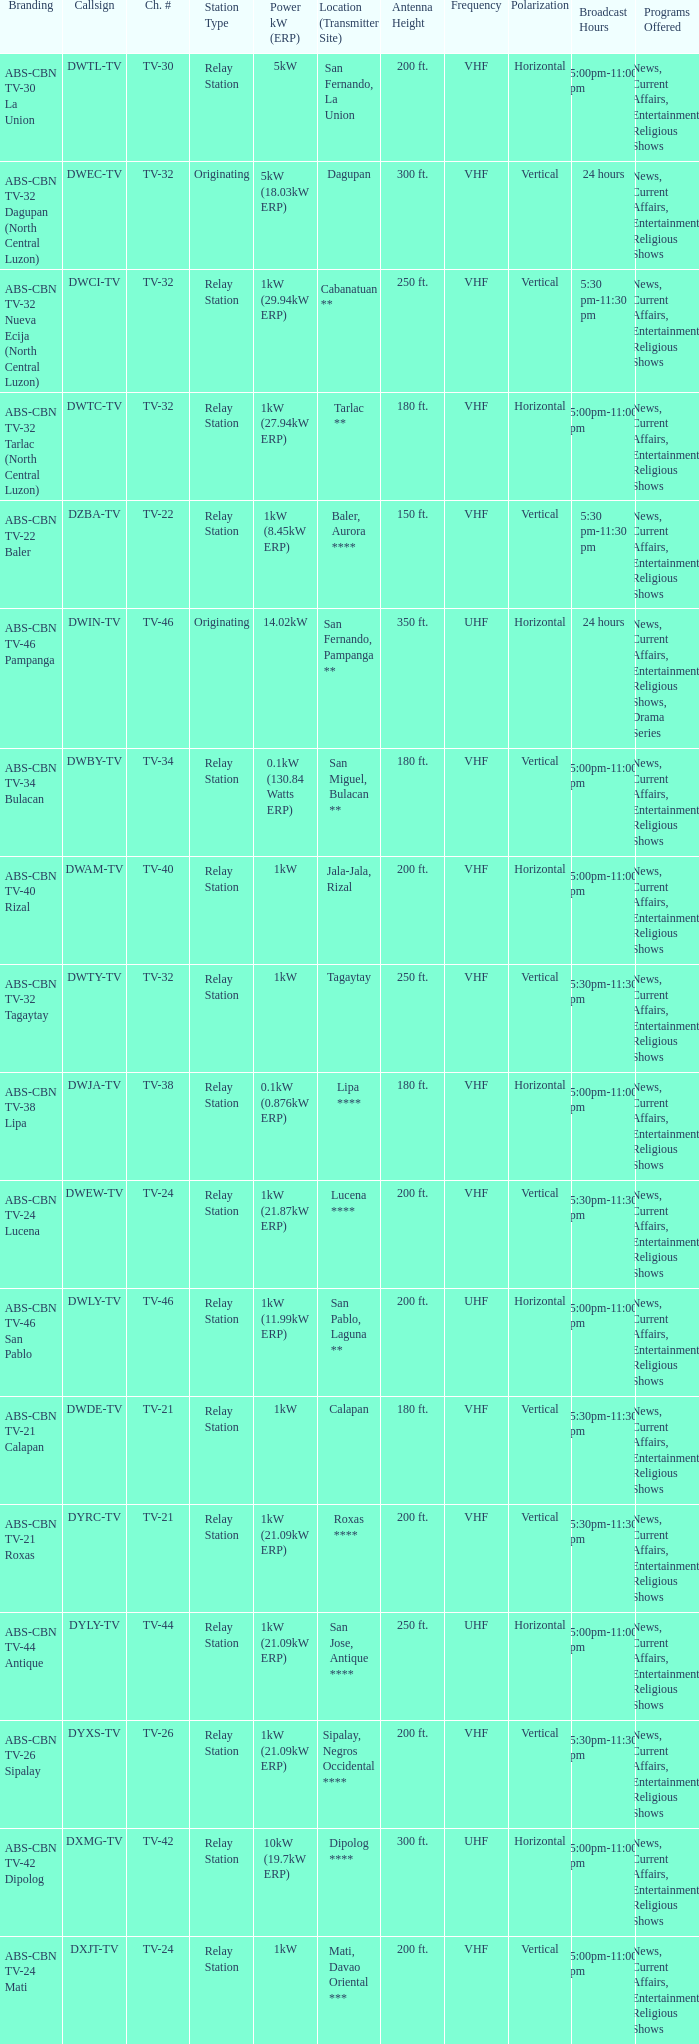Could you help me parse every detail presented in this table? {'header': ['Branding', 'Callsign', 'Ch. #', 'Station Type', 'Power kW (ERP)', 'Location (Transmitter Site)', 'Antenna Height', 'Frequency', 'Polarization', 'Broadcast Hours', 'Programs Offered'], 'rows': [['ABS-CBN TV-30 La Union', 'DWTL-TV', 'TV-30', 'Relay Station', '5kW', 'San Fernando, La Union', '200 ft.', 'VHF', 'Horizontal', '5:00pm-11:00 pm', 'News, Current Affairs, Entertainment, Religious Shows'], ['ABS-CBN TV-32 Dagupan (North Central Luzon)', 'DWEC-TV', 'TV-32', 'Originating', '5kW (18.03kW ERP)', 'Dagupan', '300 ft.', 'VHF', 'Vertical', '24 hours', 'News, Current Affairs, Entertainment, Religious Shows'], ['ABS-CBN TV-32 Nueva Ecija (North Central Luzon)', 'DWCI-TV', 'TV-32', 'Relay Station', '1kW (29.94kW ERP)', 'Cabanatuan **', '250 ft.', 'VHF', 'Vertical', '5:30 pm-11:30 pm', 'News, Current Affairs, Entertainment, Religious Shows'], ['ABS-CBN TV-32 Tarlac (North Central Luzon)', 'DWTC-TV', 'TV-32', 'Relay Station', '1kW (27.94kW ERP)', 'Tarlac **', '180 ft.', 'VHF', 'Horizontal', '5:00pm-11:00 pm', 'News, Current Affairs, Entertainment, Religious Shows'], ['ABS-CBN TV-22 Baler', 'DZBA-TV', 'TV-22', 'Relay Station', '1kW (8.45kW ERP)', 'Baler, Aurora ****', '150 ft.', 'VHF', 'Vertical', '5:30 pm-11:30 pm', 'News, Current Affairs, Entertainment, Religious Shows'], ['ABS-CBN TV-46 Pampanga', 'DWIN-TV', 'TV-46', 'Originating', '14.02kW', 'San Fernando, Pampanga **', '350 ft.', 'UHF', 'Horizontal', '24 hours', 'News, Current Affairs, Entertainment, Religious Shows, Drama Series'], ['ABS-CBN TV-34 Bulacan', 'DWBY-TV', 'TV-34', 'Relay Station', '0.1kW (130.84 Watts ERP)', 'San Miguel, Bulacan **', '180 ft.', 'VHF', 'Vertical', '5:00pm-11:00 pm', 'News, Current Affairs, Entertainment, Religious Shows'], ['ABS-CBN TV-40 Rizal', 'DWAM-TV', 'TV-40', 'Relay Station', '1kW', 'Jala-Jala, Rizal', '200 ft.', 'VHF', 'Horizontal', '5:00pm-11:00 pm', 'News, Current Affairs, Entertainment, Religious Shows'], ['ABS-CBN TV-32 Tagaytay', 'DWTY-TV', 'TV-32', 'Relay Station', '1kW', 'Tagaytay', '250 ft.', 'VHF', 'Vertical', '5:30pm-11:30 pm', 'News, Current Affairs, Entertainment, Religious Shows'], ['ABS-CBN TV-38 Lipa', 'DWJA-TV', 'TV-38', 'Relay Station', '0.1kW (0.876kW ERP)', 'Lipa ****', '180 ft.', 'VHF', 'Horizontal', '5:00pm-11:00 pm', 'News, Current Affairs, Entertainment, Religious Shows'], ['ABS-CBN TV-24 Lucena', 'DWEW-TV', 'TV-24', 'Relay Station', '1kW (21.87kW ERP)', 'Lucena ****', '200 ft.', 'VHF', 'Vertical', '5:30pm-11:30 pm', 'News, Current Affairs, Entertainment, Religious Shows'], ['ABS-CBN TV-46 San Pablo', 'DWLY-TV', 'TV-46', 'Relay Station', '1kW (11.99kW ERP)', 'San Pablo, Laguna **', '200 ft.', 'UHF', 'Horizontal', '5:00pm-11:00 pm', 'News, Current Affairs, Entertainment, Religious Shows'], ['ABS-CBN TV-21 Calapan', 'DWDE-TV', 'TV-21', 'Relay Station', '1kW', 'Calapan', '180 ft.', 'VHF', 'Vertical', '5:30pm-11:30 pm', 'News, Current Affairs, Entertainment, Religious Shows'], ['ABS-CBN TV-21 Roxas', 'DYRC-TV', 'TV-21', 'Relay Station', '1kW (21.09kW ERP)', 'Roxas ****', '200 ft.', 'VHF', 'Vertical', '5:30pm-11:30 pm', 'News, Current Affairs, Entertainment, Religious Shows'], ['ABS-CBN TV-44 Antique', 'DYLY-TV', 'TV-44', 'Relay Station', '1kW (21.09kW ERP)', 'San Jose, Antique ****', '250 ft.', 'UHF', 'Horizontal', '5:00pm-11:00 pm', 'News, Current Affairs, Entertainment, Religious Shows'], ['ABS-CBN TV-26 Sipalay', 'DYXS-TV', 'TV-26', 'Relay Station', '1kW (21.09kW ERP)', 'Sipalay, Negros Occidental ****', '200 ft.', 'VHF', 'Vertical', '5:30pm-11:30 pm', 'News, Current Affairs, Entertainment, Religious Shows'], ['ABS-CBN TV-42 Dipolog', 'DXMG-TV', 'TV-42', 'Relay Station', '10kW (19.7kW ERP)', 'Dipolog ****', '300 ft.', 'UHF', 'Horizontal', '5:00pm-11:00 pm', 'News, Current Affairs, Entertainment, Religious Shows'], ['ABS-CBN TV-24 Mati', 'DXJT-TV', 'TV-24', 'Relay Station', '1kW', 'Mati, Davao Oriental ***', '200 ft.', 'VHF', 'Vertical', '5:00pm-11:00 pm', 'News, Current Affairs, Entertainment, Religious Shows']]} What is the branding of the callsign DWCI-TV? ABS-CBN TV-32 Nueva Ecija (North Central Luzon). 